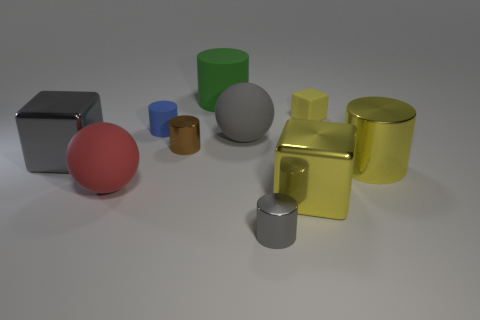Do the large ball left of the big green matte object and the small cylinder right of the big green matte cylinder have the same material?
Offer a very short reply. No. There is a metal block behind the metal cylinder to the right of the tiny gray metallic object; what is its size?
Provide a succinct answer. Large. There is a tiny object in front of the big metallic cylinder; what is it made of?
Offer a terse response. Metal. What number of objects are big spheres on the right side of the large rubber cylinder or tiny metal cylinders on the left side of the tiny gray thing?
Your answer should be very brief. 2. There is a small blue thing that is the same shape as the small brown thing; what material is it?
Ensure brevity in your answer.  Rubber. There is a shiny block that is on the left side of the red rubber ball; is its color the same as the shiny object that is to the right of the small yellow object?
Your answer should be very brief. No. Are there any gray spheres of the same size as the rubber block?
Your answer should be compact. No. What is the material of the block that is in front of the blue cylinder and on the right side of the tiny brown shiny thing?
Your answer should be compact. Metal. What number of shiny objects are either small blue cylinders or yellow cylinders?
Offer a terse response. 1. There is a small yellow thing that is the same material as the large green cylinder; what is its shape?
Give a very brief answer. Cube. 